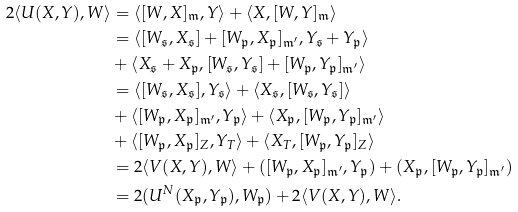Convert formula to latex. <formula><loc_0><loc_0><loc_500><loc_500>2 \langle U ( X , Y ) , W \rangle & = \langle [ W , X ] _ { \mathfrak { m } } , Y \rangle + \langle X , [ W , Y ] _ { \mathfrak { m } } \rangle \\ & = \langle [ W _ { \mathfrak { s } } , X _ { \mathfrak { s } } ] + [ W _ { \mathfrak { p } } , X _ { \mathfrak { p } } ] _ { \mathfrak { m } ^ { \prime } } , Y _ { \mathfrak { s } } + Y _ { \mathfrak { p } } \rangle \\ & + \langle X _ { \mathfrak { s } } + X _ { \mathfrak { p } } , [ W _ { \mathfrak { s } } , Y _ { \mathfrak { s } } ] + [ W _ { \mathfrak { p } } , Y _ { \mathfrak { p } } ] _ { \mathfrak { m } ^ { \prime } } \rangle \\ & = \langle [ W _ { \mathfrak { s } } , X _ { \mathfrak { s } } ] , Y _ { \mathfrak { s } } \rangle + \langle X _ { \mathfrak { s } } , [ W _ { \mathfrak { s } } , Y _ { \mathfrak { s } } ] \rangle \\ & + \langle [ W _ { \mathfrak { p } } , X _ { \mathfrak { p } } ] _ { \mathfrak { m } ^ { \prime } } , Y _ { \mathfrak { p } } \rangle + \langle X _ { \mathfrak { p } } , [ W _ { \mathfrak { p } } , Y _ { \mathfrak { p } } ] _ { \mathfrak { m } ^ { \prime } } \rangle \\ & + \langle [ W _ { \mathfrak { p } } , X _ { \mathfrak { p } } ] _ { Z } , Y _ { T } \rangle + \langle X _ { T } , [ W _ { \mathfrak { p } } , Y _ { \mathfrak { p } } ] _ { Z } \rangle \\ & = 2 \langle V ( X , Y ) , W \rangle + ( [ W _ { \mathfrak { p } } , X _ { \mathfrak { p } } ] _ { \mathfrak { m } ^ { \prime } } , Y _ { \mathfrak { p } } ) + ( X _ { \mathfrak { p } } , [ W _ { \mathfrak { p } } , Y _ { \mathfrak { p } } ] _ { \mathfrak { m } ^ { \prime } } ) \\ & = 2 ( U ^ { N } ( X _ { \mathfrak { p } } , Y _ { \mathfrak { p } } ) , W _ { \mathfrak { p } } ) + 2 \langle V ( X , Y ) , W \rangle .</formula> 